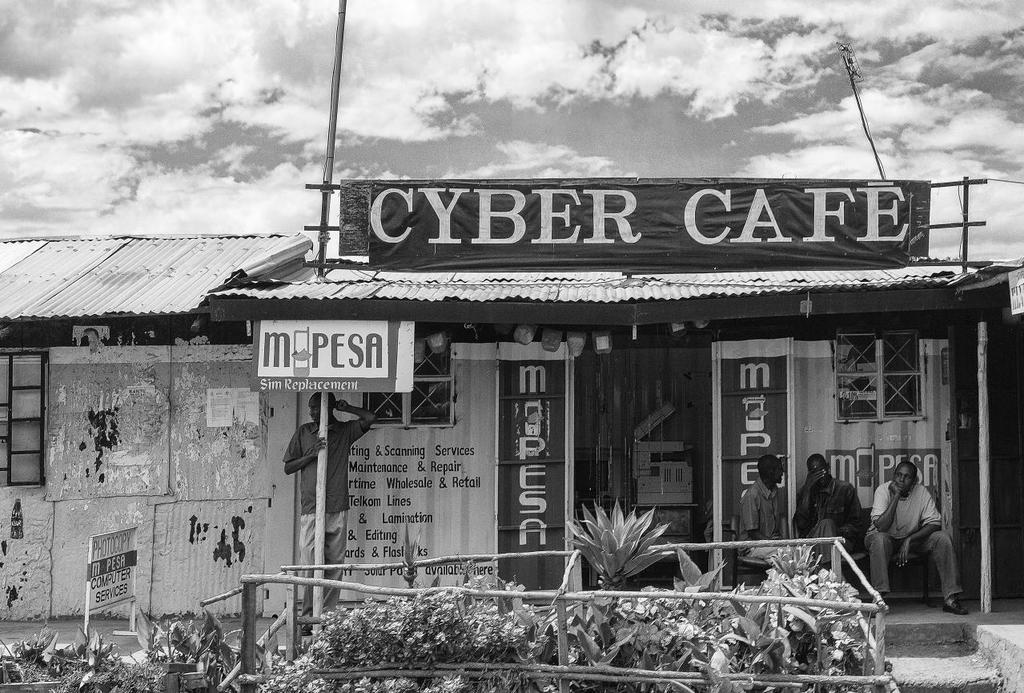What kind of cafe is this?
Your response must be concise. Cyber. What does the sign on the left read?
Your response must be concise. Unanswerable. 